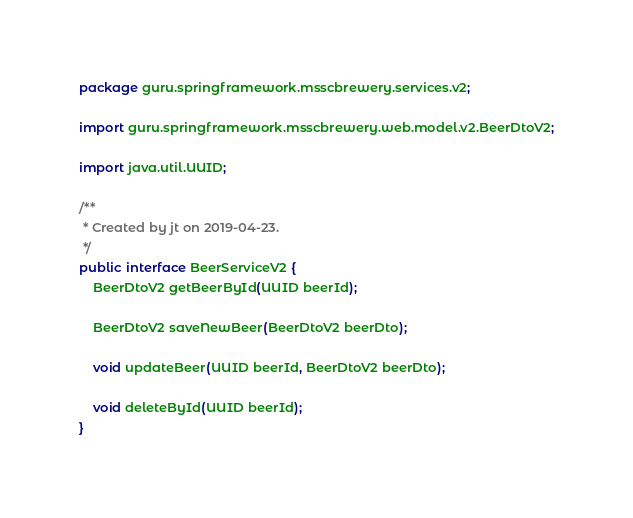Convert code to text. <code><loc_0><loc_0><loc_500><loc_500><_Java_>package guru.springframework.msscbrewery.services.v2;

import guru.springframework.msscbrewery.web.model.v2.BeerDtoV2;

import java.util.UUID;

/**
 * Created by jt on 2019-04-23.
 */
public interface BeerServiceV2 {
    BeerDtoV2 getBeerById(UUID beerId);

    BeerDtoV2 saveNewBeer(BeerDtoV2 beerDto);

    void updateBeer(UUID beerId, BeerDtoV2 beerDto);

    void deleteById(UUID beerId);
}
</code> 